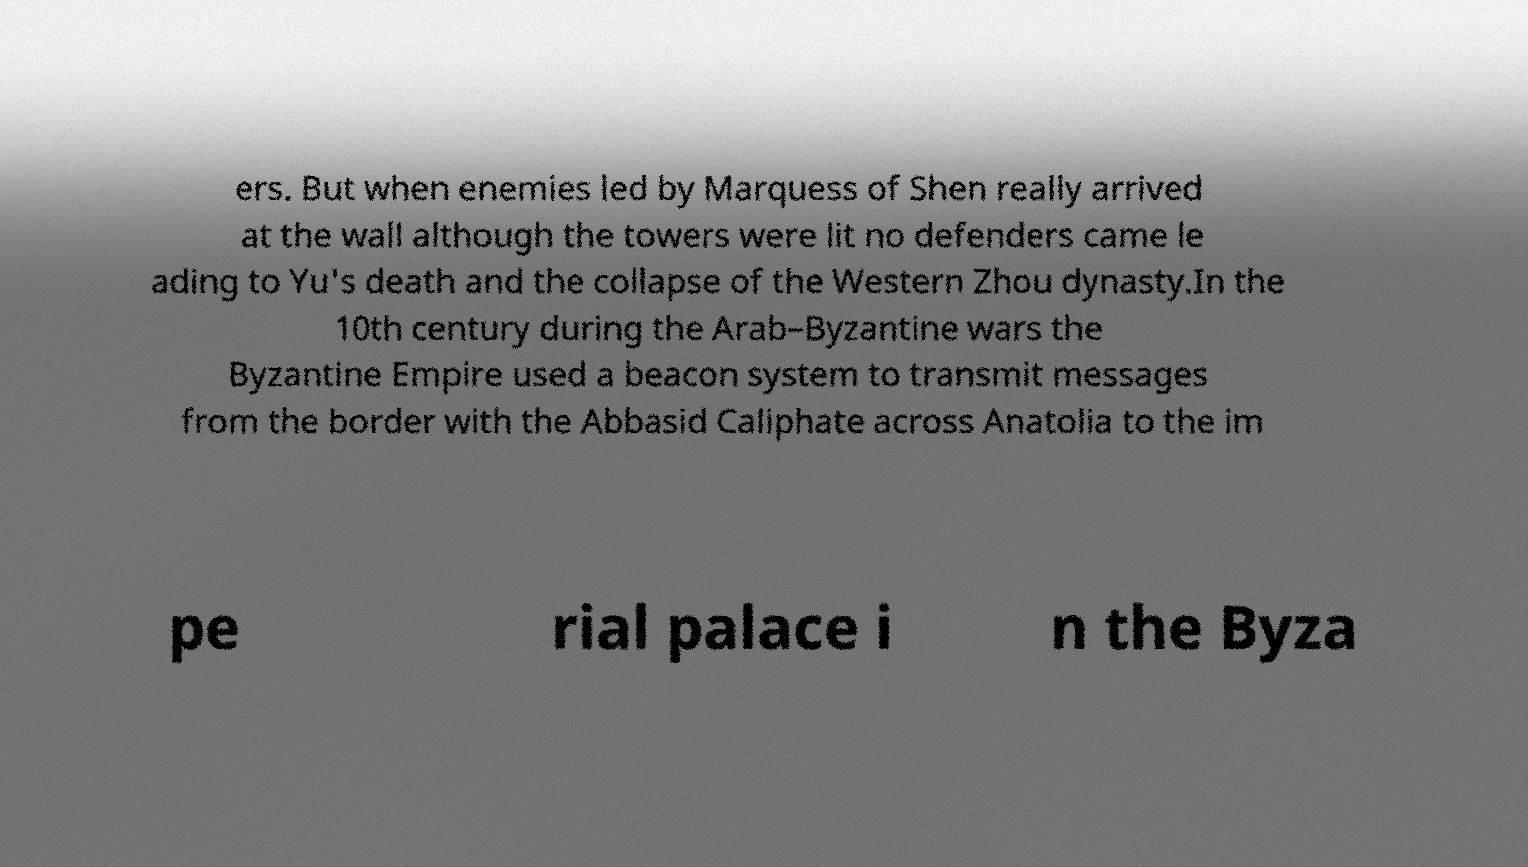Can you accurately transcribe the text from the provided image for me? ers. But when enemies led by Marquess of Shen really arrived at the wall although the towers were lit no defenders came le ading to Yu's death and the collapse of the Western Zhou dynasty.In the 10th century during the Arab–Byzantine wars the Byzantine Empire used a beacon system to transmit messages from the border with the Abbasid Caliphate across Anatolia to the im pe rial palace i n the Byza 